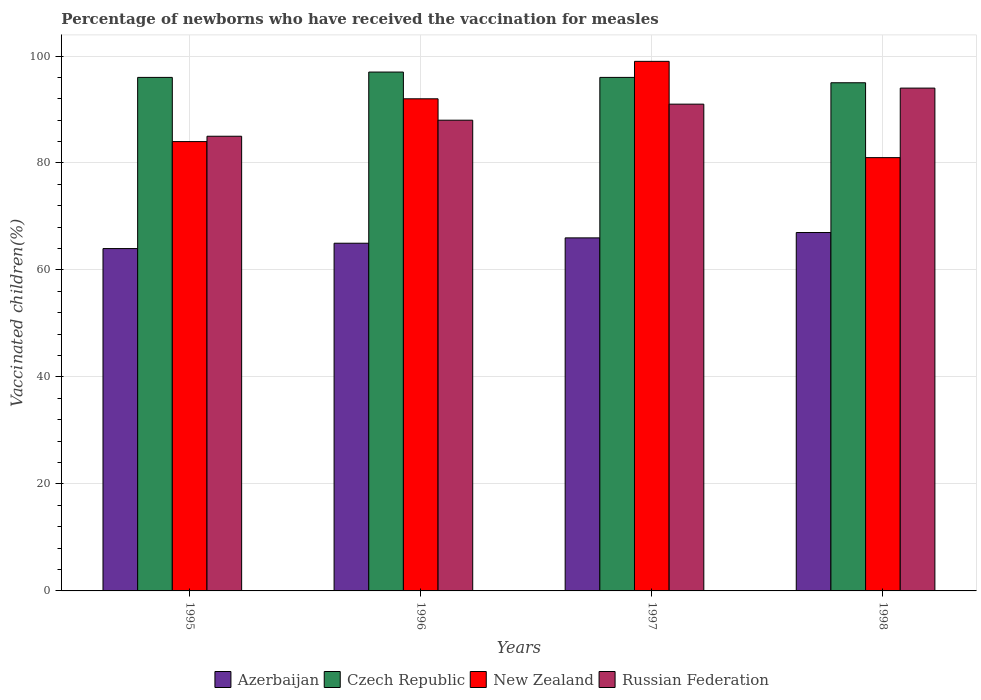How many different coloured bars are there?
Keep it short and to the point. 4. How many groups of bars are there?
Provide a succinct answer. 4. How many bars are there on the 2nd tick from the right?
Offer a very short reply. 4. In how many cases, is the number of bars for a given year not equal to the number of legend labels?
Give a very brief answer. 0. Across all years, what is the maximum percentage of vaccinated children in Czech Republic?
Provide a short and direct response. 97. Across all years, what is the minimum percentage of vaccinated children in New Zealand?
Keep it short and to the point. 81. In which year was the percentage of vaccinated children in Czech Republic maximum?
Offer a very short reply. 1996. What is the total percentage of vaccinated children in Azerbaijan in the graph?
Your response must be concise. 262. What is the difference between the percentage of vaccinated children in Azerbaijan in 1995 and that in 1997?
Your answer should be compact. -2. What is the average percentage of vaccinated children in Azerbaijan per year?
Ensure brevity in your answer.  65.5. In the year 1997, what is the difference between the percentage of vaccinated children in Russian Federation and percentage of vaccinated children in Azerbaijan?
Your response must be concise. 25. What is the ratio of the percentage of vaccinated children in Czech Republic in 1995 to that in 1997?
Your answer should be compact. 1. Is the percentage of vaccinated children in Russian Federation in 1996 less than that in 1997?
Your answer should be very brief. Yes. Is the difference between the percentage of vaccinated children in Russian Federation in 1996 and 1997 greater than the difference between the percentage of vaccinated children in Azerbaijan in 1996 and 1997?
Provide a short and direct response. No. What is the difference between the highest and the second highest percentage of vaccinated children in Azerbaijan?
Provide a succinct answer. 1. What is the difference between the highest and the lowest percentage of vaccinated children in Azerbaijan?
Ensure brevity in your answer.  3. Is the sum of the percentage of vaccinated children in Czech Republic in 1996 and 1997 greater than the maximum percentage of vaccinated children in Russian Federation across all years?
Your response must be concise. Yes. What does the 2nd bar from the left in 1998 represents?
Make the answer very short. Czech Republic. What does the 1st bar from the right in 1997 represents?
Ensure brevity in your answer.  Russian Federation. Is it the case that in every year, the sum of the percentage of vaccinated children in New Zealand and percentage of vaccinated children in Czech Republic is greater than the percentage of vaccinated children in Azerbaijan?
Offer a very short reply. Yes. How many bars are there?
Offer a terse response. 16. Are all the bars in the graph horizontal?
Provide a succinct answer. No. How many years are there in the graph?
Keep it short and to the point. 4. What is the difference between two consecutive major ticks on the Y-axis?
Provide a succinct answer. 20. Does the graph contain grids?
Make the answer very short. Yes. What is the title of the graph?
Offer a terse response. Percentage of newborns who have received the vaccination for measles. Does "Chad" appear as one of the legend labels in the graph?
Your answer should be compact. No. What is the label or title of the X-axis?
Give a very brief answer. Years. What is the label or title of the Y-axis?
Make the answer very short. Vaccinated children(%). What is the Vaccinated children(%) in Azerbaijan in 1995?
Your answer should be very brief. 64. What is the Vaccinated children(%) in Czech Republic in 1995?
Your answer should be compact. 96. What is the Vaccinated children(%) in New Zealand in 1995?
Give a very brief answer. 84. What is the Vaccinated children(%) in Czech Republic in 1996?
Your answer should be very brief. 97. What is the Vaccinated children(%) in New Zealand in 1996?
Make the answer very short. 92. What is the Vaccinated children(%) of Czech Republic in 1997?
Make the answer very short. 96. What is the Vaccinated children(%) in Russian Federation in 1997?
Your answer should be very brief. 91. What is the Vaccinated children(%) in Russian Federation in 1998?
Give a very brief answer. 94. Across all years, what is the maximum Vaccinated children(%) of Czech Republic?
Your answer should be very brief. 97. Across all years, what is the maximum Vaccinated children(%) of Russian Federation?
Your answer should be very brief. 94. Across all years, what is the minimum Vaccinated children(%) in Czech Republic?
Provide a succinct answer. 95. Across all years, what is the minimum Vaccinated children(%) in Russian Federation?
Ensure brevity in your answer.  85. What is the total Vaccinated children(%) of Azerbaijan in the graph?
Give a very brief answer. 262. What is the total Vaccinated children(%) in Czech Republic in the graph?
Give a very brief answer. 384. What is the total Vaccinated children(%) in New Zealand in the graph?
Keep it short and to the point. 356. What is the total Vaccinated children(%) in Russian Federation in the graph?
Keep it short and to the point. 358. What is the difference between the Vaccinated children(%) in Azerbaijan in 1995 and that in 1996?
Ensure brevity in your answer.  -1. What is the difference between the Vaccinated children(%) of Czech Republic in 1995 and that in 1996?
Your response must be concise. -1. What is the difference between the Vaccinated children(%) in New Zealand in 1995 and that in 1997?
Ensure brevity in your answer.  -15. What is the difference between the Vaccinated children(%) of Russian Federation in 1995 and that in 1997?
Your answer should be very brief. -6. What is the difference between the Vaccinated children(%) in Azerbaijan in 1995 and that in 1998?
Keep it short and to the point. -3. What is the difference between the Vaccinated children(%) of Czech Republic in 1995 and that in 1998?
Your response must be concise. 1. What is the difference between the Vaccinated children(%) in New Zealand in 1995 and that in 1998?
Provide a short and direct response. 3. What is the difference between the Vaccinated children(%) in Azerbaijan in 1996 and that in 1997?
Your answer should be very brief. -1. What is the difference between the Vaccinated children(%) in Czech Republic in 1996 and that in 1997?
Provide a succinct answer. 1. What is the difference between the Vaccinated children(%) in New Zealand in 1996 and that in 1997?
Your answer should be very brief. -7. What is the difference between the Vaccinated children(%) in Russian Federation in 1996 and that in 1997?
Provide a short and direct response. -3. What is the difference between the Vaccinated children(%) in Czech Republic in 1996 and that in 1998?
Your response must be concise. 2. What is the difference between the Vaccinated children(%) of New Zealand in 1997 and that in 1998?
Make the answer very short. 18. What is the difference between the Vaccinated children(%) of Azerbaijan in 1995 and the Vaccinated children(%) of Czech Republic in 1996?
Keep it short and to the point. -33. What is the difference between the Vaccinated children(%) in Azerbaijan in 1995 and the Vaccinated children(%) in New Zealand in 1996?
Your response must be concise. -28. What is the difference between the Vaccinated children(%) of Czech Republic in 1995 and the Vaccinated children(%) of New Zealand in 1996?
Make the answer very short. 4. What is the difference between the Vaccinated children(%) of Azerbaijan in 1995 and the Vaccinated children(%) of Czech Republic in 1997?
Your response must be concise. -32. What is the difference between the Vaccinated children(%) of Azerbaijan in 1995 and the Vaccinated children(%) of New Zealand in 1997?
Your response must be concise. -35. What is the difference between the Vaccinated children(%) in Azerbaijan in 1995 and the Vaccinated children(%) in Russian Federation in 1997?
Keep it short and to the point. -27. What is the difference between the Vaccinated children(%) of Czech Republic in 1995 and the Vaccinated children(%) of New Zealand in 1997?
Your answer should be very brief. -3. What is the difference between the Vaccinated children(%) of Czech Republic in 1995 and the Vaccinated children(%) of Russian Federation in 1997?
Your answer should be compact. 5. What is the difference between the Vaccinated children(%) in New Zealand in 1995 and the Vaccinated children(%) in Russian Federation in 1997?
Your response must be concise. -7. What is the difference between the Vaccinated children(%) in Azerbaijan in 1995 and the Vaccinated children(%) in Czech Republic in 1998?
Provide a short and direct response. -31. What is the difference between the Vaccinated children(%) in Azerbaijan in 1995 and the Vaccinated children(%) in New Zealand in 1998?
Offer a terse response. -17. What is the difference between the Vaccinated children(%) in New Zealand in 1995 and the Vaccinated children(%) in Russian Federation in 1998?
Make the answer very short. -10. What is the difference between the Vaccinated children(%) of Azerbaijan in 1996 and the Vaccinated children(%) of Czech Republic in 1997?
Give a very brief answer. -31. What is the difference between the Vaccinated children(%) of Azerbaijan in 1996 and the Vaccinated children(%) of New Zealand in 1997?
Keep it short and to the point. -34. What is the difference between the Vaccinated children(%) of New Zealand in 1996 and the Vaccinated children(%) of Russian Federation in 1997?
Provide a short and direct response. 1. What is the difference between the Vaccinated children(%) in Azerbaijan in 1996 and the Vaccinated children(%) in Czech Republic in 1998?
Offer a very short reply. -30. What is the difference between the Vaccinated children(%) of Azerbaijan in 1996 and the Vaccinated children(%) of New Zealand in 1998?
Keep it short and to the point. -16. What is the difference between the Vaccinated children(%) in Azerbaijan in 1996 and the Vaccinated children(%) in Russian Federation in 1998?
Your answer should be very brief. -29. What is the difference between the Vaccinated children(%) of Azerbaijan in 1997 and the Vaccinated children(%) of Czech Republic in 1998?
Your answer should be very brief. -29. What is the difference between the Vaccinated children(%) in Azerbaijan in 1997 and the Vaccinated children(%) in Russian Federation in 1998?
Make the answer very short. -28. What is the difference between the Vaccinated children(%) of Czech Republic in 1997 and the Vaccinated children(%) of New Zealand in 1998?
Keep it short and to the point. 15. What is the difference between the Vaccinated children(%) in New Zealand in 1997 and the Vaccinated children(%) in Russian Federation in 1998?
Provide a succinct answer. 5. What is the average Vaccinated children(%) of Azerbaijan per year?
Your answer should be compact. 65.5. What is the average Vaccinated children(%) in Czech Republic per year?
Provide a succinct answer. 96. What is the average Vaccinated children(%) in New Zealand per year?
Provide a succinct answer. 89. What is the average Vaccinated children(%) of Russian Federation per year?
Provide a succinct answer. 89.5. In the year 1995, what is the difference between the Vaccinated children(%) in Azerbaijan and Vaccinated children(%) in Czech Republic?
Provide a succinct answer. -32. In the year 1995, what is the difference between the Vaccinated children(%) of Azerbaijan and Vaccinated children(%) of Russian Federation?
Keep it short and to the point. -21. In the year 1995, what is the difference between the Vaccinated children(%) of Czech Republic and Vaccinated children(%) of New Zealand?
Give a very brief answer. 12. In the year 1996, what is the difference between the Vaccinated children(%) in Azerbaijan and Vaccinated children(%) in Czech Republic?
Your answer should be very brief. -32. In the year 1996, what is the difference between the Vaccinated children(%) of New Zealand and Vaccinated children(%) of Russian Federation?
Your response must be concise. 4. In the year 1997, what is the difference between the Vaccinated children(%) in Azerbaijan and Vaccinated children(%) in Czech Republic?
Ensure brevity in your answer.  -30. In the year 1997, what is the difference between the Vaccinated children(%) in Azerbaijan and Vaccinated children(%) in New Zealand?
Provide a short and direct response. -33. In the year 1997, what is the difference between the Vaccinated children(%) in Czech Republic and Vaccinated children(%) in New Zealand?
Your response must be concise. -3. In the year 1997, what is the difference between the Vaccinated children(%) of Czech Republic and Vaccinated children(%) of Russian Federation?
Ensure brevity in your answer.  5. In the year 1998, what is the difference between the Vaccinated children(%) in Czech Republic and Vaccinated children(%) in New Zealand?
Ensure brevity in your answer.  14. What is the ratio of the Vaccinated children(%) of Azerbaijan in 1995 to that in 1996?
Provide a short and direct response. 0.98. What is the ratio of the Vaccinated children(%) in Russian Federation in 1995 to that in 1996?
Provide a succinct answer. 0.97. What is the ratio of the Vaccinated children(%) in Azerbaijan in 1995 to that in 1997?
Keep it short and to the point. 0.97. What is the ratio of the Vaccinated children(%) of Czech Republic in 1995 to that in 1997?
Keep it short and to the point. 1. What is the ratio of the Vaccinated children(%) of New Zealand in 1995 to that in 1997?
Your answer should be very brief. 0.85. What is the ratio of the Vaccinated children(%) of Russian Federation in 1995 to that in 1997?
Offer a very short reply. 0.93. What is the ratio of the Vaccinated children(%) in Azerbaijan in 1995 to that in 1998?
Ensure brevity in your answer.  0.96. What is the ratio of the Vaccinated children(%) in Czech Republic in 1995 to that in 1998?
Offer a terse response. 1.01. What is the ratio of the Vaccinated children(%) of Russian Federation in 1995 to that in 1998?
Your answer should be very brief. 0.9. What is the ratio of the Vaccinated children(%) in Czech Republic in 1996 to that in 1997?
Offer a terse response. 1.01. What is the ratio of the Vaccinated children(%) in New Zealand in 1996 to that in 1997?
Your answer should be compact. 0.93. What is the ratio of the Vaccinated children(%) in Azerbaijan in 1996 to that in 1998?
Offer a terse response. 0.97. What is the ratio of the Vaccinated children(%) in Czech Republic in 1996 to that in 1998?
Make the answer very short. 1.02. What is the ratio of the Vaccinated children(%) in New Zealand in 1996 to that in 1998?
Offer a terse response. 1.14. What is the ratio of the Vaccinated children(%) of Russian Federation in 1996 to that in 1998?
Provide a succinct answer. 0.94. What is the ratio of the Vaccinated children(%) of Azerbaijan in 1997 to that in 1998?
Your answer should be very brief. 0.99. What is the ratio of the Vaccinated children(%) in Czech Republic in 1997 to that in 1998?
Your answer should be compact. 1.01. What is the ratio of the Vaccinated children(%) in New Zealand in 1997 to that in 1998?
Make the answer very short. 1.22. What is the ratio of the Vaccinated children(%) of Russian Federation in 1997 to that in 1998?
Provide a succinct answer. 0.97. What is the difference between the highest and the second highest Vaccinated children(%) in New Zealand?
Provide a short and direct response. 7. What is the difference between the highest and the second highest Vaccinated children(%) of Russian Federation?
Your answer should be very brief. 3. What is the difference between the highest and the lowest Vaccinated children(%) in Czech Republic?
Your answer should be very brief. 2. 